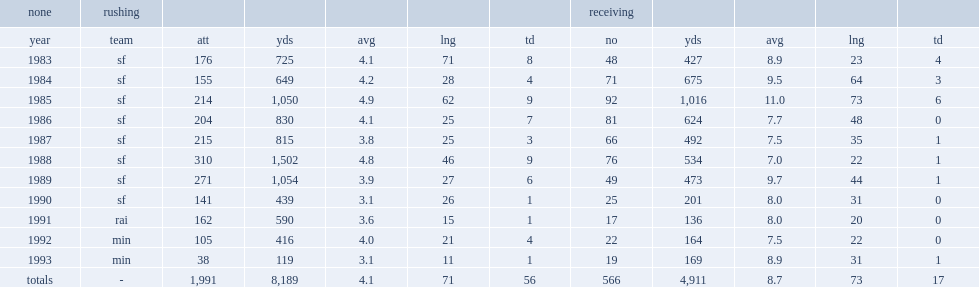Could you parse the entire table? {'header': ['none', 'rushing', '', '', '', '', '', 'receiving', '', '', '', ''], 'rows': [['year', 'team', 'att', 'yds', 'avg', 'lng', 'td', 'no', 'yds', 'avg', 'lng', 'td'], ['1983', 'sf', '176', '725', '4.1', '71', '8', '48', '427', '8.9', '23', '4'], ['1984', 'sf', '155', '649', '4.2', '28', '4', '71', '675', '9.5', '64', '3'], ['1985', 'sf', '214', '1,050', '4.9', '62', '9', '92', '1,016', '11.0', '73', '6'], ['1986', 'sf', '204', '830', '4.1', '25', '7', '81', '624', '7.7', '48', '0'], ['1987', 'sf', '215', '815', '3.8', '25', '3', '66', '492', '7.5', '35', '1'], ['1988', 'sf', '310', '1,502', '4.8', '46', '9', '76', '534', '7.0', '22', '1'], ['1989', 'sf', '271', '1,054', '3.9', '27', '6', '49', '473', '9.7', '44', '1'], ['1990', 'sf', '141', '439', '3.1', '26', '1', '25', '201', '8.0', '31', '0'], ['1991', 'rai', '162', '590', '3.6', '15', '1', '17', '136', '8.0', '20', '0'], ['1992', 'min', '105', '416', '4.0', '21', '4', '22', '164', '7.5', '22', '0'], ['1993', 'min', '38', '119', '3.1', '11', '1', '19', '169', '8.9', '31', '1'], ['totals', '-', '1,991', '8,189', '4.1', '71', '56', '566', '4,911', '8.7', '73', '17']]} In total, how many rushing yards did craig finish during his eleven nfl seasons? 8189.0. 